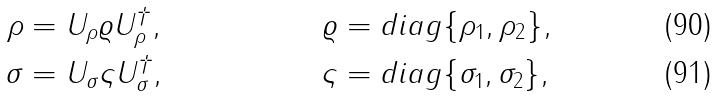Convert formula to latex. <formula><loc_0><loc_0><loc_500><loc_500>\rho & = U _ { \rho } \varrho U ^ { \dagger } _ { \rho } , & \varrho & = d i a g \{ \rho _ { 1 } , \rho _ { 2 } \} , \\ \sigma & = U _ { \sigma } \varsigma U ^ { \dagger } _ { \sigma } , & \varsigma & = d i a g \{ \sigma _ { 1 } , \sigma _ { 2 } \} ,</formula> 